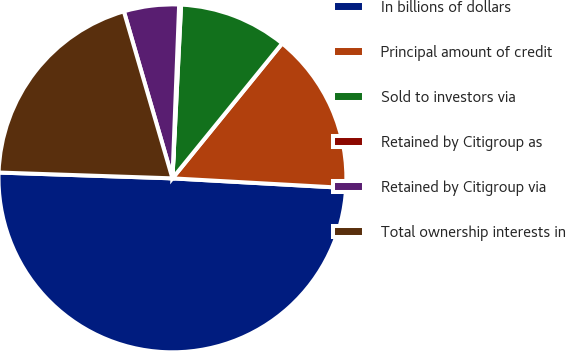Convert chart to OTSL. <chart><loc_0><loc_0><loc_500><loc_500><pie_chart><fcel>In billions of dollars<fcel>Principal amount of credit<fcel>Sold to investors via<fcel>Retained by Citigroup as<fcel>Retained by Citigroup via<fcel>Total ownership interests in<nl><fcel>49.65%<fcel>15.02%<fcel>10.07%<fcel>0.18%<fcel>5.12%<fcel>19.96%<nl></chart> 